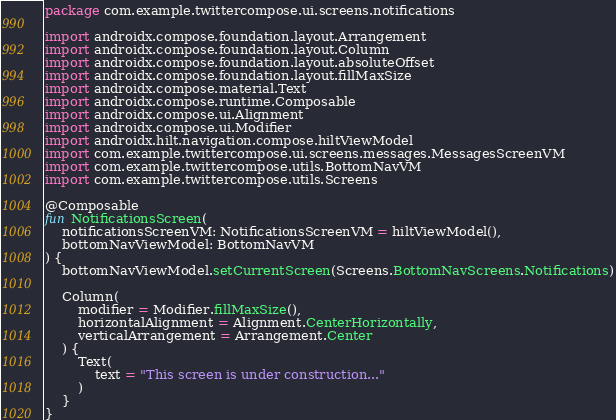<code> <loc_0><loc_0><loc_500><loc_500><_Kotlin_>package com.example.twittercompose.ui.screens.notifications

import androidx.compose.foundation.layout.Arrangement
import androidx.compose.foundation.layout.Column
import androidx.compose.foundation.layout.absoluteOffset
import androidx.compose.foundation.layout.fillMaxSize
import androidx.compose.material.Text
import androidx.compose.runtime.Composable
import androidx.compose.ui.Alignment
import androidx.compose.ui.Modifier
import androidx.hilt.navigation.compose.hiltViewModel
import com.example.twittercompose.ui.screens.messages.MessagesScreenVM
import com.example.twittercompose.utils.BottomNavVM
import com.example.twittercompose.utils.Screens

@Composable
fun NotificationsScreen(
    notificationsScreenVM: NotificationsScreenVM = hiltViewModel(),
    bottomNavViewModel: BottomNavVM
) {
    bottomNavViewModel.setCurrentScreen(Screens.BottomNavScreens.Notifications)

    Column(
        modifier = Modifier.fillMaxSize(),
        horizontalAlignment = Alignment.CenterHorizontally,
        verticalArrangement = Arrangement.Center
    ) {
        Text(
            text = "This screen is under construction..."
        )
    }
}
</code> 